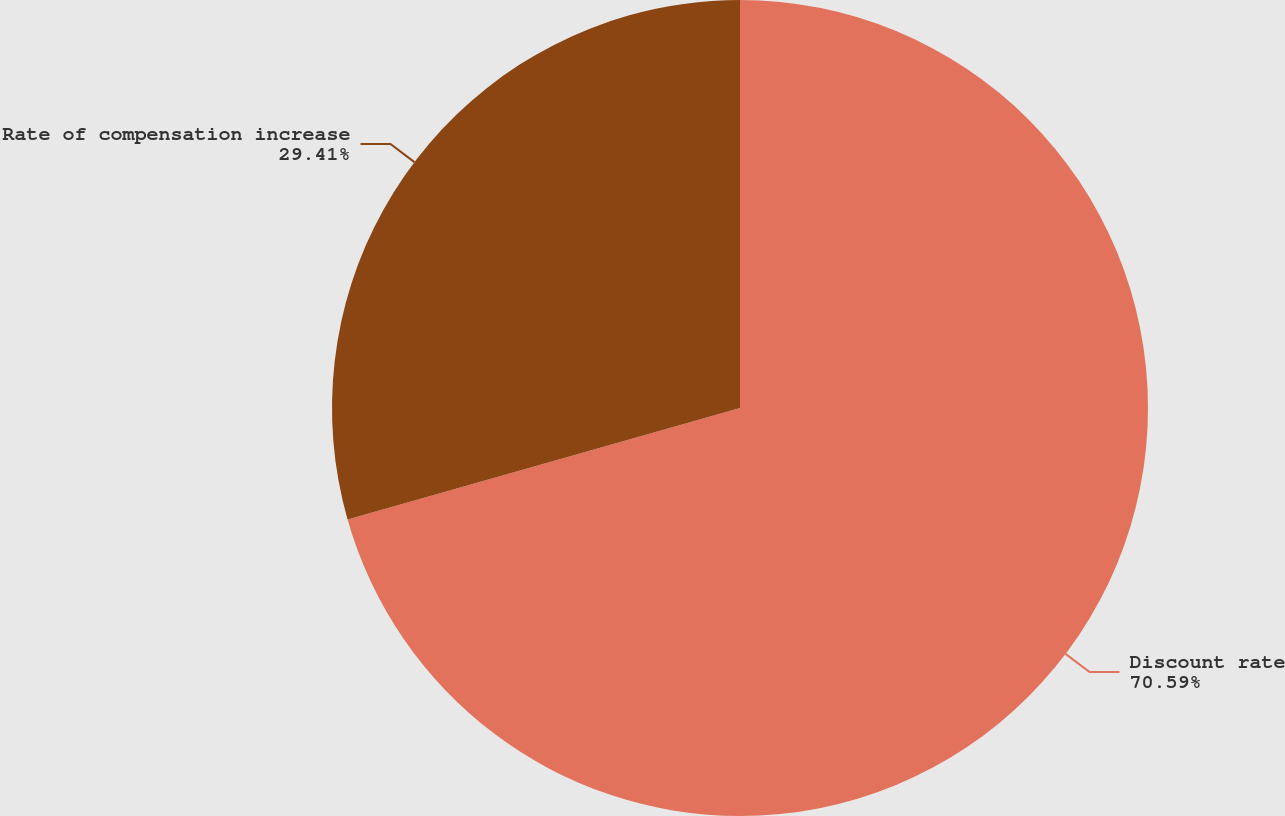<chart> <loc_0><loc_0><loc_500><loc_500><pie_chart><fcel>Discount rate<fcel>Rate of compensation increase<nl><fcel>70.59%<fcel>29.41%<nl></chart> 